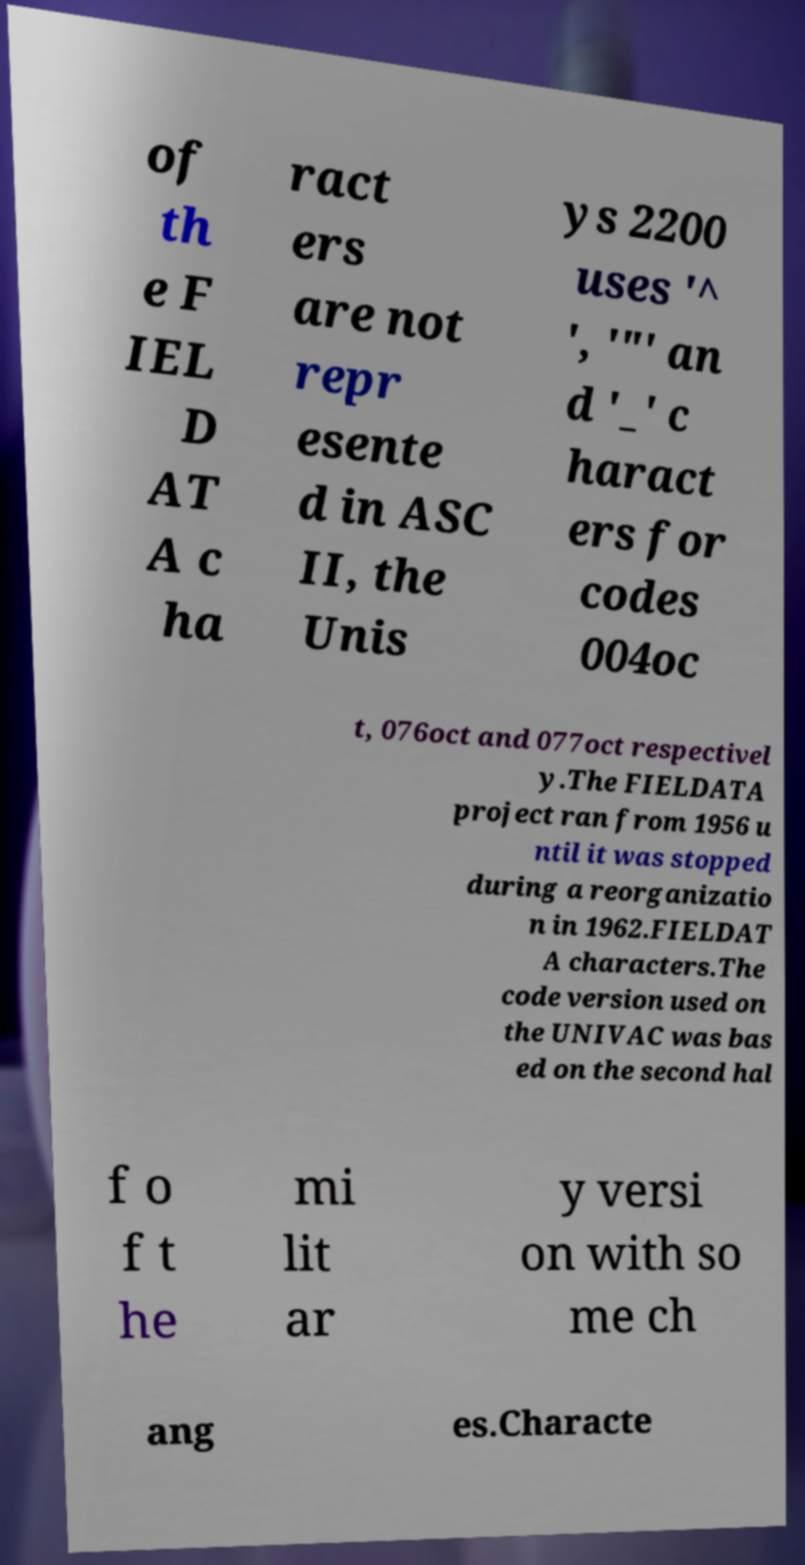I need the written content from this picture converted into text. Can you do that? of th e F IEL D AT A c ha ract ers are not repr esente d in ASC II, the Unis ys 2200 uses '^ ', '"' an d '_' c haract ers for codes 004oc t, 076oct and 077oct respectivel y.The FIELDATA project ran from 1956 u ntil it was stopped during a reorganizatio n in 1962.FIELDAT A characters.The code version used on the UNIVAC was bas ed on the second hal f o f t he mi lit ar y versi on with so me ch ang es.Characte 